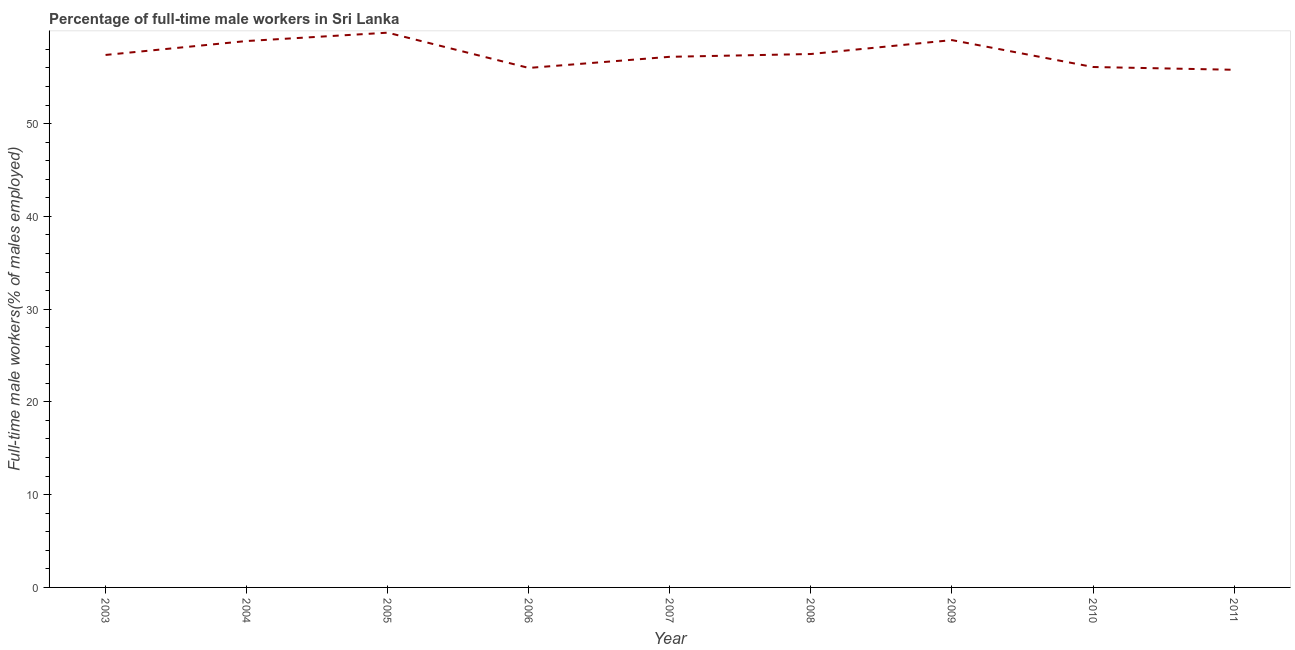What is the percentage of full-time male workers in 2011?
Provide a succinct answer. 55.8. Across all years, what is the maximum percentage of full-time male workers?
Make the answer very short. 59.8. Across all years, what is the minimum percentage of full-time male workers?
Provide a succinct answer. 55.8. In which year was the percentage of full-time male workers minimum?
Make the answer very short. 2011. What is the sum of the percentage of full-time male workers?
Your answer should be very brief. 517.7. What is the difference between the percentage of full-time male workers in 2005 and 2008?
Provide a succinct answer. 2.3. What is the average percentage of full-time male workers per year?
Your answer should be very brief. 57.52. What is the median percentage of full-time male workers?
Make the answer very short. 57.4. What is the ratio of the percentage of full-time male workers in 2006 to that in 2007?
Offer a very short reply. 0.98. Is the difference between the percentage of full-time male workers in 2005 and 2007 greater than the difference between any two years?
Give a very brief answer. No. What is the difference between the highest and the second highest percentage of full-time male workers?
Ensure brevity in your answer.  0.8. Is the sum of the percentage of full-time male workers in 2010 and 2011 greater than the maximum percentage of full-time male workers across all years?
Your answer should be very brief. Yes. What is the difference between the highest and the lowest percentage of full-time male workers?
Your answer should be very brief. 4. In how many years, is the percentage of full-time male workers greater than the average percentage of full-time male workers taken over all years?
Provide a succinct answer. 3. Does the percentage of full-time male workers monotonically increase over the years?
Offer a terse response. No. Are the values on the major ticks of Y-axis written in scientific E-notation?
Give a very brief answer. No. Does the graph contain grids?
Keep it short and to the point. No. What is the title of the graph?
Offer a very short reply. Percentage of full-time male workers in Sri Lanka. What is the label or title of the Y-axis?
Provide a short and direct response. Full-time male workers(% of males employed). What is the Full-time male workers(% of males employed) in 2003?
Your response must be concise. 57.4. What is the Full-time male workers(% of males employed) of 2004?
Make the answer very short. 58.9. What is the Full-time male workers(% of males employed) of 2005?
Your answer should be very brief. 59.8. What is the Full-time male workers(% of males employed) in 2006?
Give a very brief answer. 56. What is the Full-time male workers(% of males employed) of 2007?
Provide a succinct answer. 57.2. What is the Full-time male workers(% of males employed) of 2008?
Provide a succinct answer. 57.5. What is the Full-time male workers(% of males employed) in 2010?
Your answer should be compact. 56.1. What is the Full-time male workers(% of males employed) of 2011?
Ensure brevity in your answer.  55.8. What is the difference between the Full-time male workers(% of males employed) in 2003 and 2004?
Offer a terse response. -1.5. What is the difference between the Full-time male workers(% of males employed) in 2003 and 2005?
Provide a succinct answer. -2.4. What is the difference between the Full-time male workers(% of males employed) in 2003 and 2007?
Your answer should be compact. 0.2. What is the difference between the Full-time male workers(% of males employed) in 2003 and 2008?
Give a very brief answer. -0.1. What is the difference between the Full-time male workers(% of males employed) in 2003 and 2010?
Offer a very short reply. 1.3. What is the difference between the Full-time male workers(% of males employed) in 2003 and 2011?
Offer a terse response. 1.6. What is the difference between the Full-time male workers(% of males employed) in 2004 and 2005?
Offer a very short reply. -0.9. What is the difference between the Full-time male workers(% of males employed) in 2004 and 2007?
Give a very brief answer. 1.7. What is the difference between the Full-time male workers(% of males employed) in 2004 and 2009?
Provide a succinct answer. -0.1. What is the difference between the Full-time male workers(% of males employed) in 2004 and 2010?
Ensure brevity in your answer.  2.8. What is the difference between the Full-time male workers(% of males employed) in 2004 and 2011?
Make the answer very short. 3.1. What is the difference between the Full-time male workers(% of males employed) in 2005 and 2007?
Provide a succinct answer. 2.6. What is the difference between the Full-time male workers(% of males employed) in 2005 and 2008?
Ensure brevity in your answer.  2.3. What is the difference between the Full-time male workers(% of males employed) in 2005 and 2010?
Keep it short and to the point. 3.7. What is the difference between the Full-time male workers(% of males employed) in 2006 and 2010?
Keep it short and to the point. -0.1. What is the difference between the Full-time male workers(% of males employed) in 2006 and 2011?
Your answer should be compact. 0.2. What is the difference between the Full-time male workers(% of males employed) in 2007 and 2008?
Make the answer very short. -0.3. What is the difference between the Full-time male workers(% of males employed) in 2007 and 2009?
Your response must be concise. -1.8. What is the difference between the Full-time male workers(% of males employed) in 2007 and 2011?
Your response must be concise. 1.4. What is the difference between the Full-time male workers(% of males employed) in 2008 and 2009?
Keep it short and to the point. -1.5. What is the ratio of the Full-time male workers(% of males employed) in 2003 to that in 2004?
Your answer should be very brief. 0.97. What is the ratio of the Full-time male workers(% of males employed) in 2003 to that in 2005?
Your response must be concise. 0.96. What is the ratio of the Full-time male workers(% of males employed) in 2003 to that in 2007?
Make the answer very short. 1. What is the ratio of the Full-time male workers(% of males employed) in 2003 to that in 2010?
Your answer should be compact. 1.02. What is the ratio of the Full-time male workers(% of males employed) in 2004 to that in 2005?
Keep it short and to the point. 0.98. What is the ratio of the Full-time male workers(% of males employed) in 2004 to that in 2006?
Ensure brevity in your answer.  1.05. What is the ratio of the Full-time male workers(% of males employed) in 2004 to that in 2009?
Ensure brevity in your answer.  1. What is the ratio of the Full-time male workers(% of males employed) in 2004 to that in 2010?
Your response must be concise. 1.05. What is the ratio of the Full-time male workers(% of males employed) in 2004 to that in 2011?
Your answer should be very brief. 1.06. What is the ratio of the Full-time male workers(% of males employed) in 2005 to that in 2006?
Give a very brief answer. 1.07. What is the ratio of the Full-time male workers(% of males employed) in 2005 to that in 2007?
Keep it short and to the point. 1.04. What is the ratio of the Full-time male workers(% of males employed) in 2005 to that in 2008?
Provide a succinct answer. 1.04. What is the ratio of the Full-time male workers(% of males employed) in 2005 to that in 2010?
Your answer should be very brief. 1.07. What is the ratio of the Full-time male workers(% of males employed) in 2005 to that in 2011?
Offer a very short reply. 1.07. What is the ratio of the Full-time male workers(% of males employed) in 2006 to that in 2007?
Give a very brief answer. 0.98. What is the ratio of the Full-time male workers(% of males employed) in 2006 to that in 2008?
Ensure brevity in your answer.  0.97. What is the ratio of the Full-time male workers(% of males employed) in 2006 to that in 2009?
Keep it short and to the point. 0.95. What is the ratio of the Full-time male workers(% of males employed) in 2007 to that in 2008?
Provide a succinct answer. 0.99. What is the ratio of the Full-time male workers(% of males employed) in 2008 to that in 2010?
Give a very brief answer. 1.02. What is the ratio of the Full-time male workers(% of males employed) in 2009 to that in 2010?
Ensure brevity in your answer.  1.05. What is the ratio of the Full-time male workers(% of males employed) in 2009 to that in 2011?
Your answer should be very brief. 1.06. 